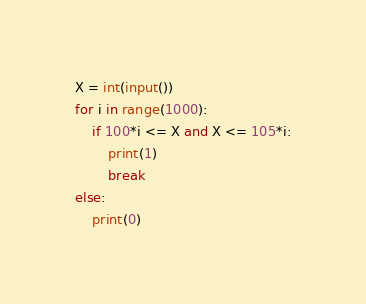Convert code to text. <code><loc_0><loc_0><loc_500><loc_500><_Python_>X = int(input())
for i in range(1000):
    if 100*i <= X and X <= 105*i:
        print(1)
        break
else:
    print(0)
</code> 